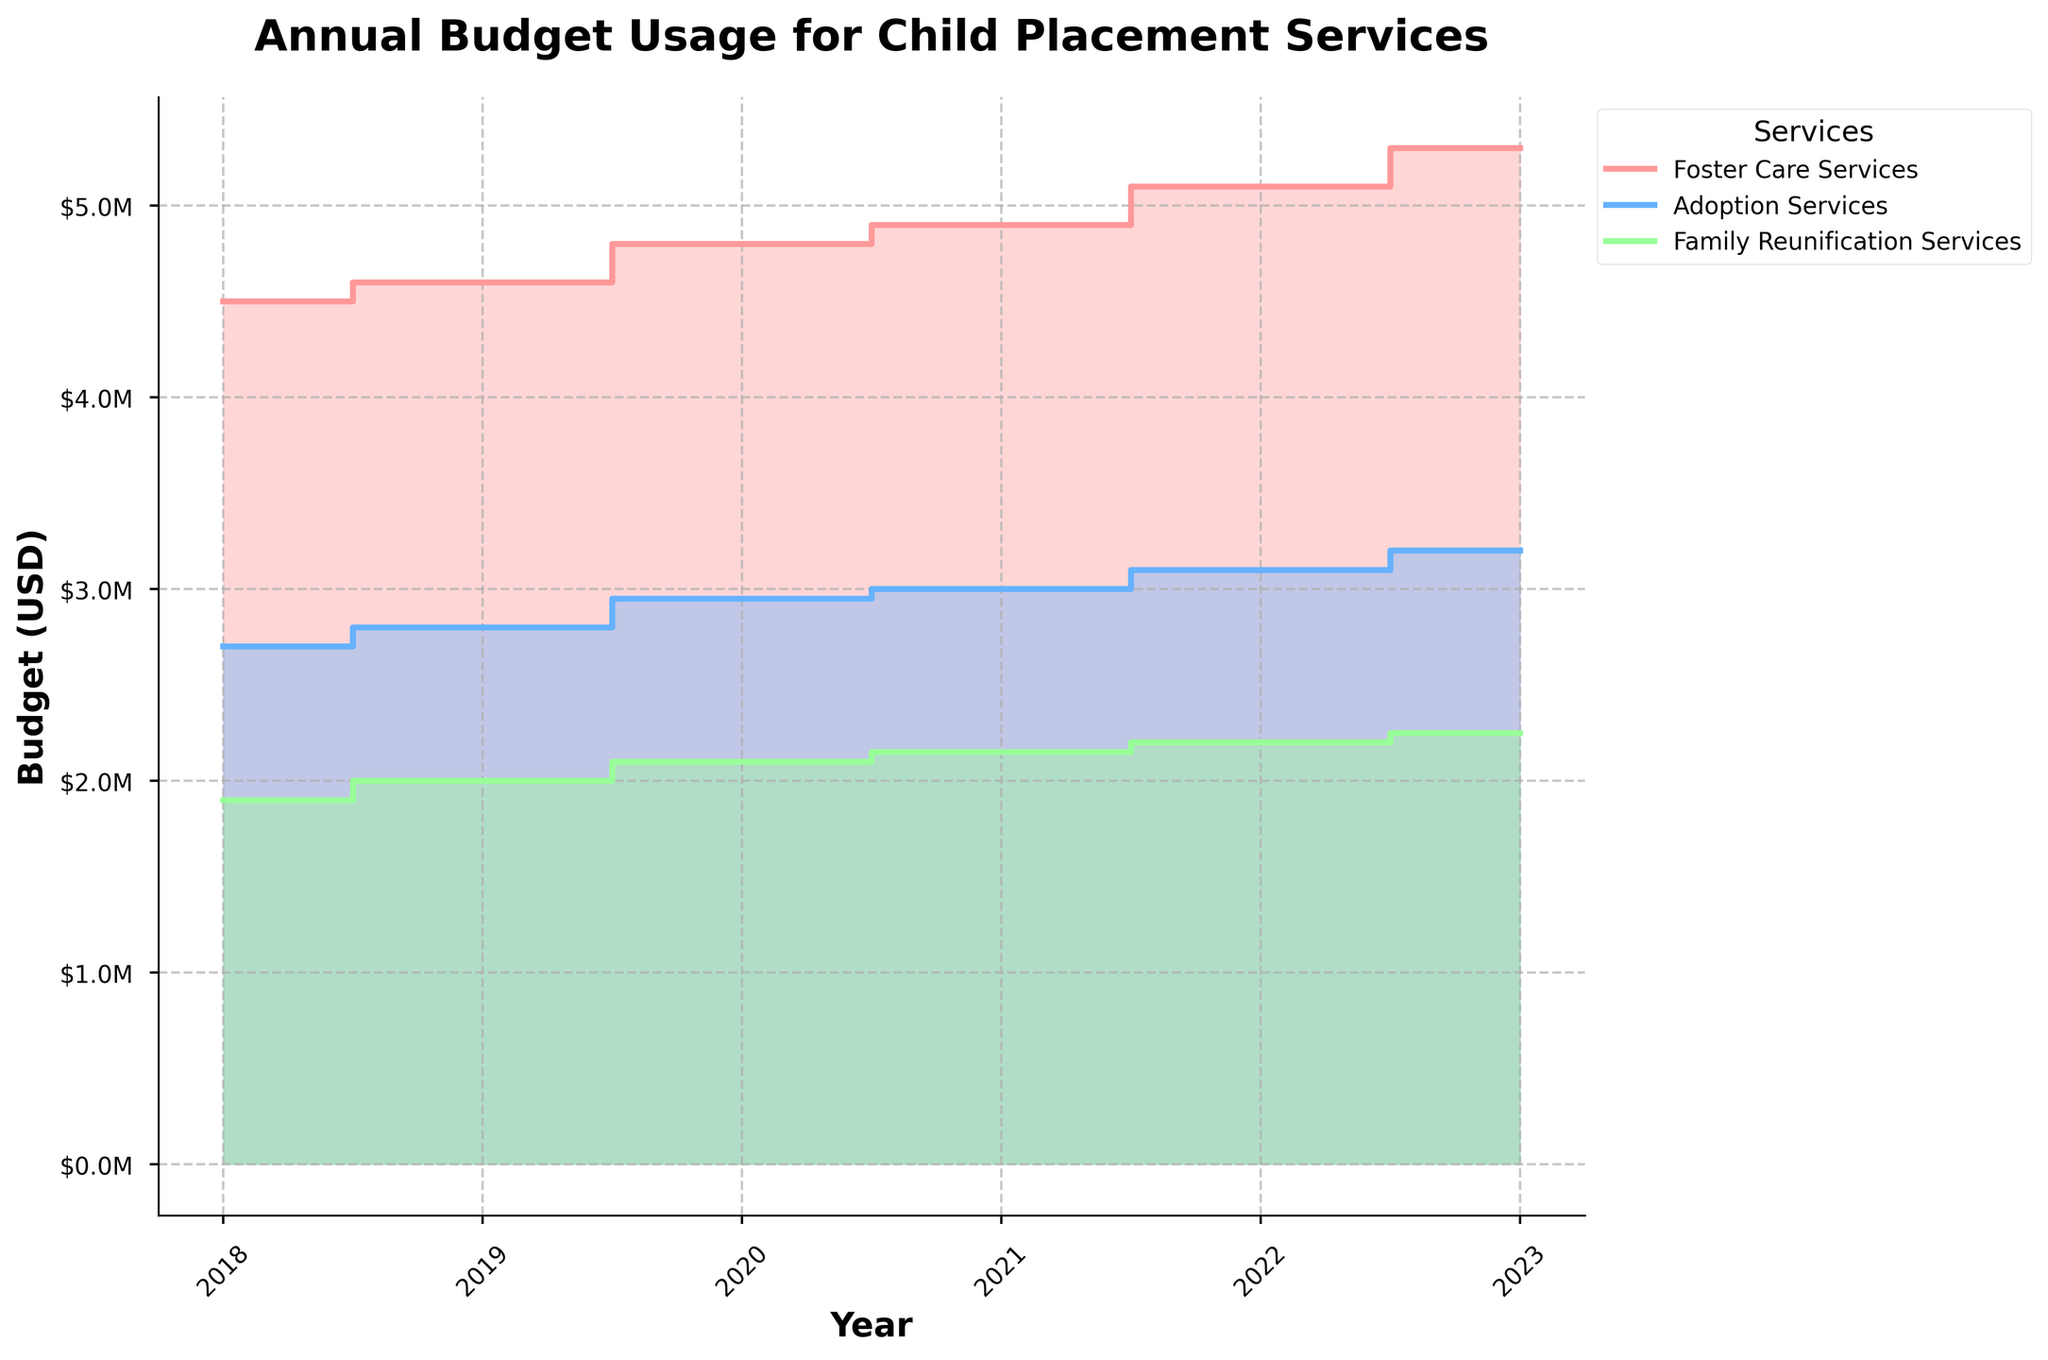What's the title of the figure? The title is typically found at the top of the figure, providing an overview of what the chart is about. In this case, the title is clearly stated.
Answer: Annual Budget Usage for Child Placement Services What is the range of years presented in the figure? The range of years can be identified by looking at the x-axis, which shows the start and end years of the data presented.
Answer: 2018 to 2023 Which service had the highest allocated budget in 2023? To determine this, observe the plotted data points or filled areas on the step chart for 2023 and compare the heights representing the allocated budgets for each service.
Answer: Foster Care Services How does the used budget for Family Reunification Services in 2020 compare to the allocated budget for the same service in 2019? First, identify the used budget for Family Reunification Services in 2020 from the chart, and then find the allocated budget for the same service in 2019. Compare the two values.
Answer: The used budget in 2020 is higher than the allocated budget in 2019 What is the overall trend in the used budget for Adoption Services from 2018 to 2023? Observe the plotted steps and filled area that represent the used budget for Adoption Services and note the general direction of changes.
Answer: Increasing Which year shows the largest difference between allocated and used budget for Foster Care Services? For each year, calculate the difference between the allocated and used budget for Foster Care Services and find the year with the largest difference.
Answer: 2023 What percentage of the allocated budget was used for Family Reunification Services in 2022? Find the allocated and used budget for 2022, then compute the percentage by dividing the used budget by the allocated budget and multiplying by 100. ($2,200,000 ÷ $2,400,000) * 100
Answer: 91.7% Are there any years where the used budget exceeds the allocated budget for any service? Scan through the plotted data to check if the used budget for any service at any year surpasses the allocated budget, looking for steps in the chart that go over the allocated lines.
Answer: No Which service had the most consistent yearly increase in used budget from 2018 to 2023? Examine the step increases for each service and identify which has the least variation and a steady increase over the years.
Answer: Foster Care Services 